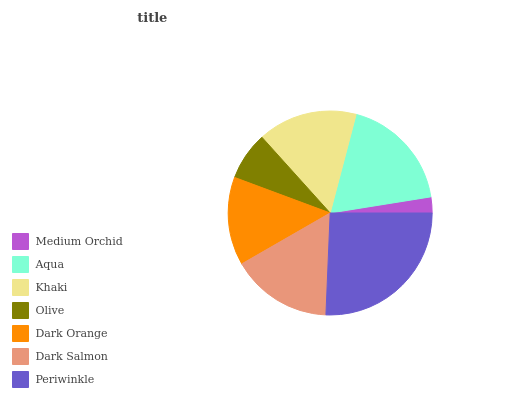Is Medium Orchid the minimum?
Answer yes or no. Yes. Is Periwinkle the maximum?
Answer yes or no. Yes. Is Aqua the minimum?
Answer yes or no. No. Is Aqua the maximum?
Answer yes or no. No. Is Aqua greater than Medium Orchid?
Answer yes or no. Yes. Is Medium Orchid less than Aqua?
Answer yes or no. Yes. Is Medium Orchid greater than Aqua?
Answer yes or no. No. Is Aqua less than Medium Orchid?
Answer yes or no. No. Is Khaki the high median?
Answer yes or no. Yes. Is Khaki the low median?
Answer yes or no. Yes. Is Dark Salmon the high median?
Answer yes or no. No. Is Medium Orchid the low median?
Answer yes or no. No. 